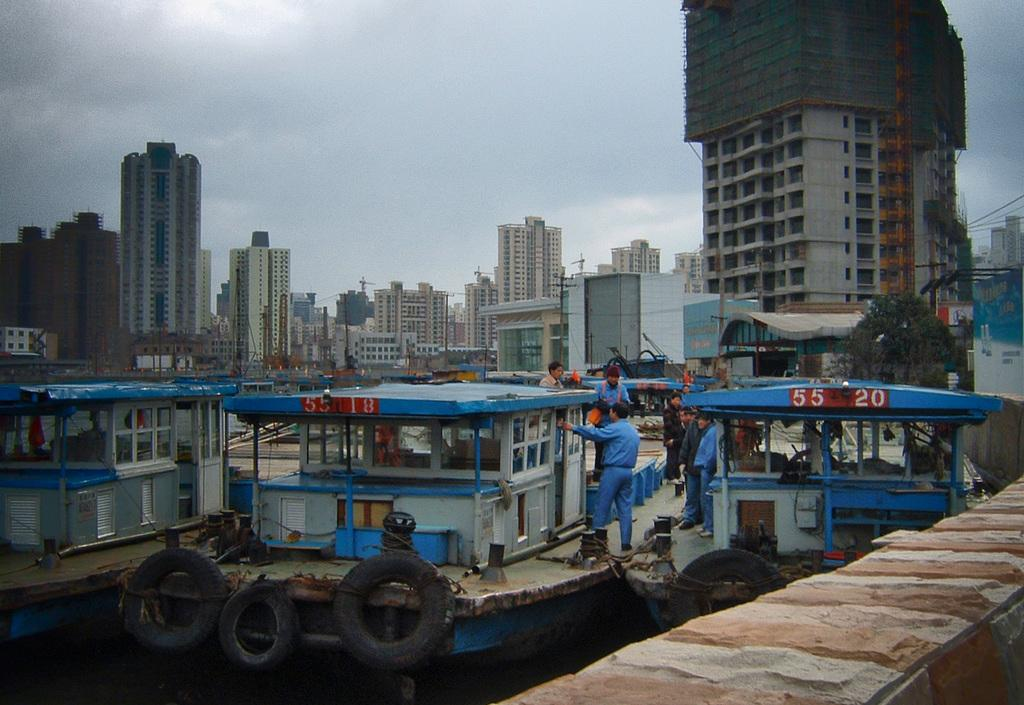What objects can be seen in the image related to transportation? There are tyres and boats in the image. What else can be seen in the image besides transportation-related objects? There are people and buildings in the image. What is visible in the background of the image? The sky is visible in the background of the image. How many times does the quarter twist in the image? There is no quarter present in the image, so it cannot twist. What is the process of crushing the tyres in the image? There is no crushing of tyres depicted in the image. 